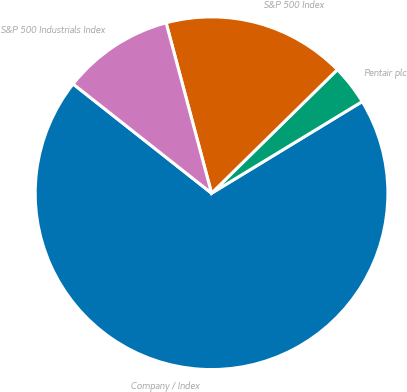Convert chart to OTSL. <chart><loc_0><loc_0><loc_500><loc_500><pie_chart><fcel>Company / Index<fcel>Pentair plc<fcel>S&P 500 Index<fcel>S&P 500 Industrials Index<nl><fcel>69.33%<fcel>3.66%<fcel>16.79%<fcel>10.22%<nl></chart> 